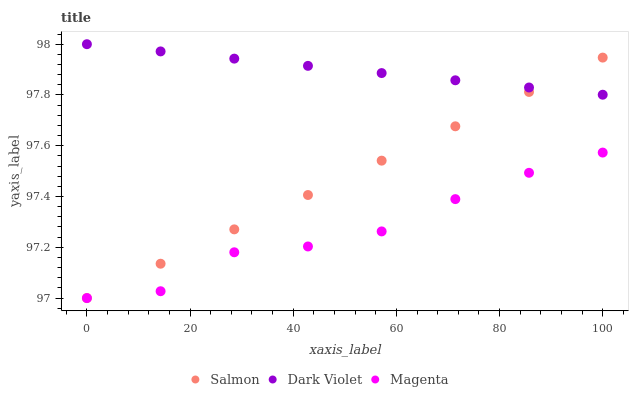Does Magenta have the minimum area under the curve?
Answer yes or no. Yes. Does Dark Violet have the maximum area under the curve?
Answer yes or no. Yes. Does Salmon have the minimum area under the curve?
Answer yes or no. No. Does Salmon have the maximum area under the curve?
Answer yes or no. No. Is Salmon the smoothest?
Answer yes or no. Yes. Is Magenta the roughest?
Answer yes or no. Yes. Is Dark Violet the smoothest?
Answer yes or no. No. Is Dark Violet the roughest?
Answer yes or no. No. Does Magenta have the lowest value?
Answer yes or no. Yes. Does Dark Violet have the lowest value?
Answer yes or no. No. Does Dark Violet have the highest value?
Answer yes or no. Yes. Does Salmon have the highest value?
Answer yes or no. No. Is Magenta less than Dark Violet?
Answer yes or no. Yes. Is Dark Violet greater than Magenta?
Answer yes or no. Yes. Does Dark Violet intersect Salmon?
Answer yes or no. Yes. Is Dark Violet less than Salmon?
Answer yes or no. No. Is Dark Violet greater than Salmon?
Answer yes or no. No. Does Magenta intersect Dark Violet?
Answer yes or no. No. 